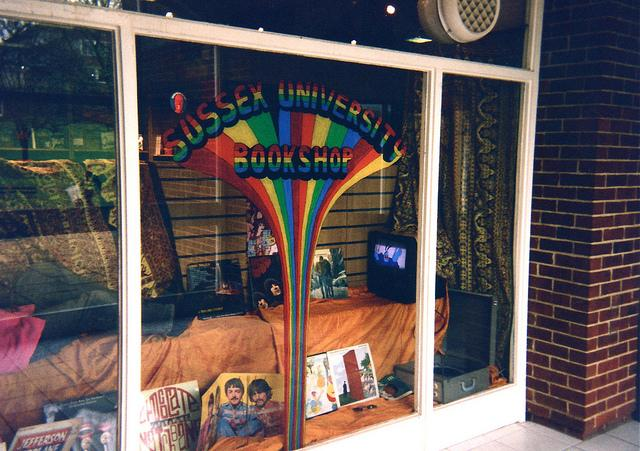What type of clientele does the book store have?

Choices:
A) gay
B) nazis
C) jamaicans
D) african americans gay 